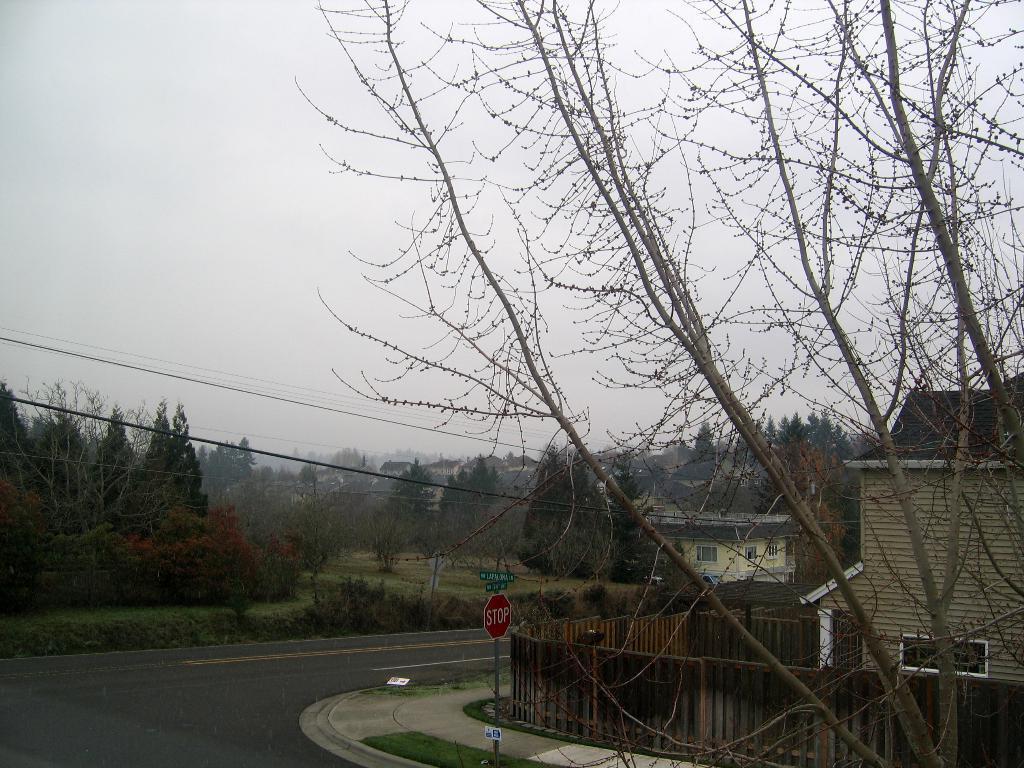How would you summarize this image in a sentence or two? In this image there is the sky truncated towards the top of the image, there are trees, there are trees truncated towards the left of the image, there is grass, there are plants, there are houses, there is a house truncated towards the right of the image, there is a fencing truncated towards the right of the image, there is a pole, there are boards on the pole, there is text on the boards, there is road truncated towards the bottom of the image, there are wires truncated towards the left of the image, there is an object on the road. 